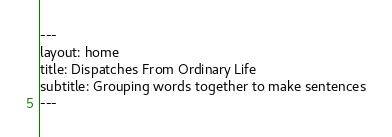Convert code to text. <code><loc_0><loc_0><loc_500><loc_500><_HTML_>---
layout: home
title: Dispatches From Ordinary Life
subtitle: Grouping words together to make sentences
---
</code> 